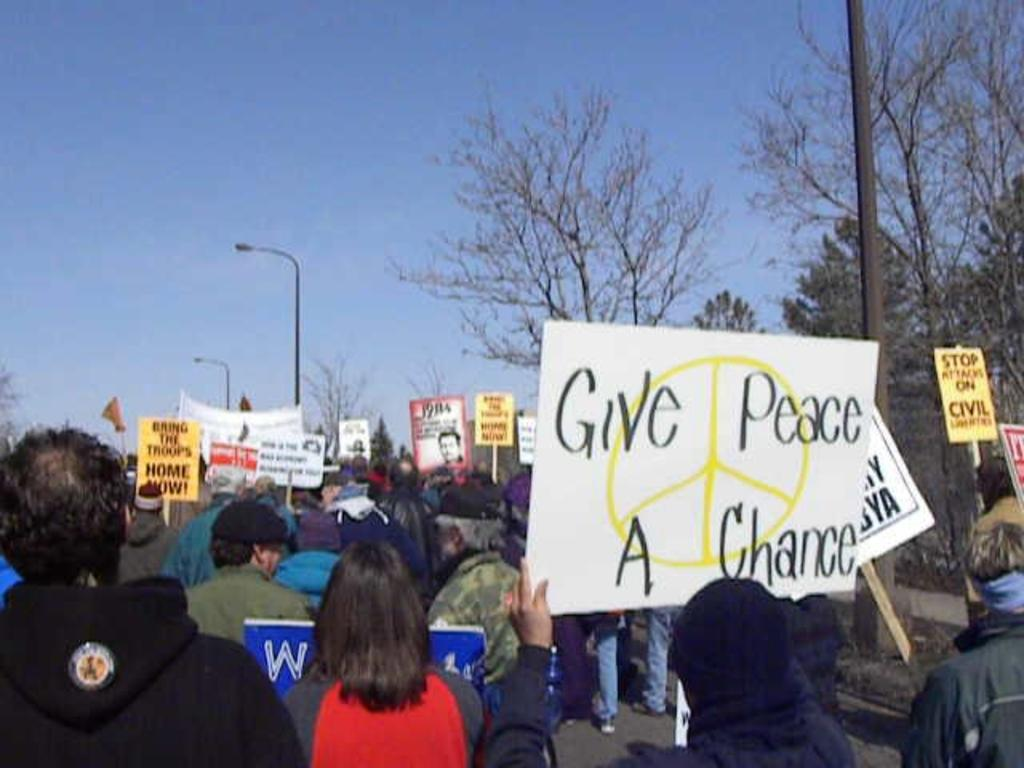<image>
Give a short and clear explanation of the subsequent image. A protest in which signs are held promoting peace. 